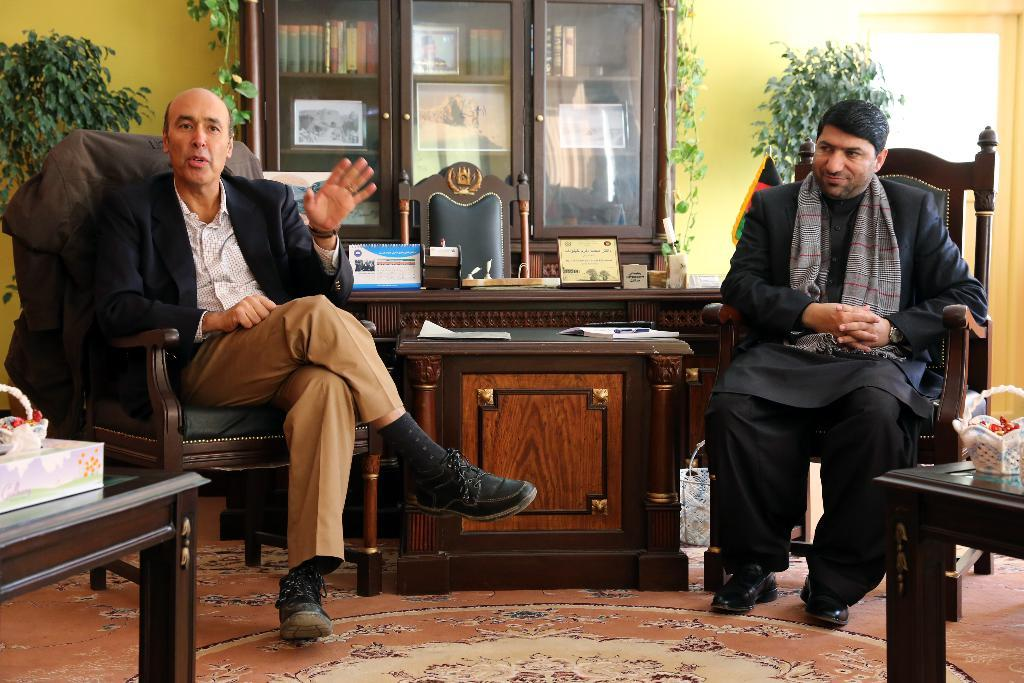How many people are in the image? There are two men in the image. What are the men doing in the image? The men are sitting on chairs. Where are the chairs located in relation to the table? The chairs are in front of a table. What other furniture can be seen in the image? There is a cupboard in the image. What type of vegetation is present in the image? There are plants in the image. Can you describe any other objects in the image? There are other objects present in the image, but their specific details are not mentioned in the provided facts. In which direction are the men turning the page in the image? There is no page present in the image, so it is not possible to determine the direction in which the men might be turning a page. 